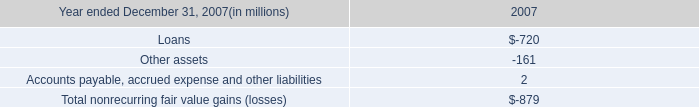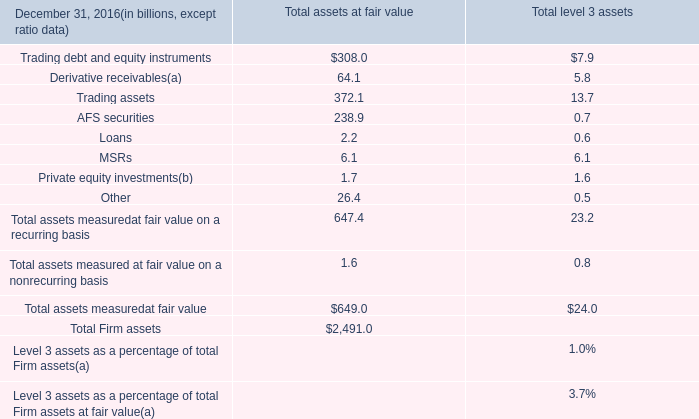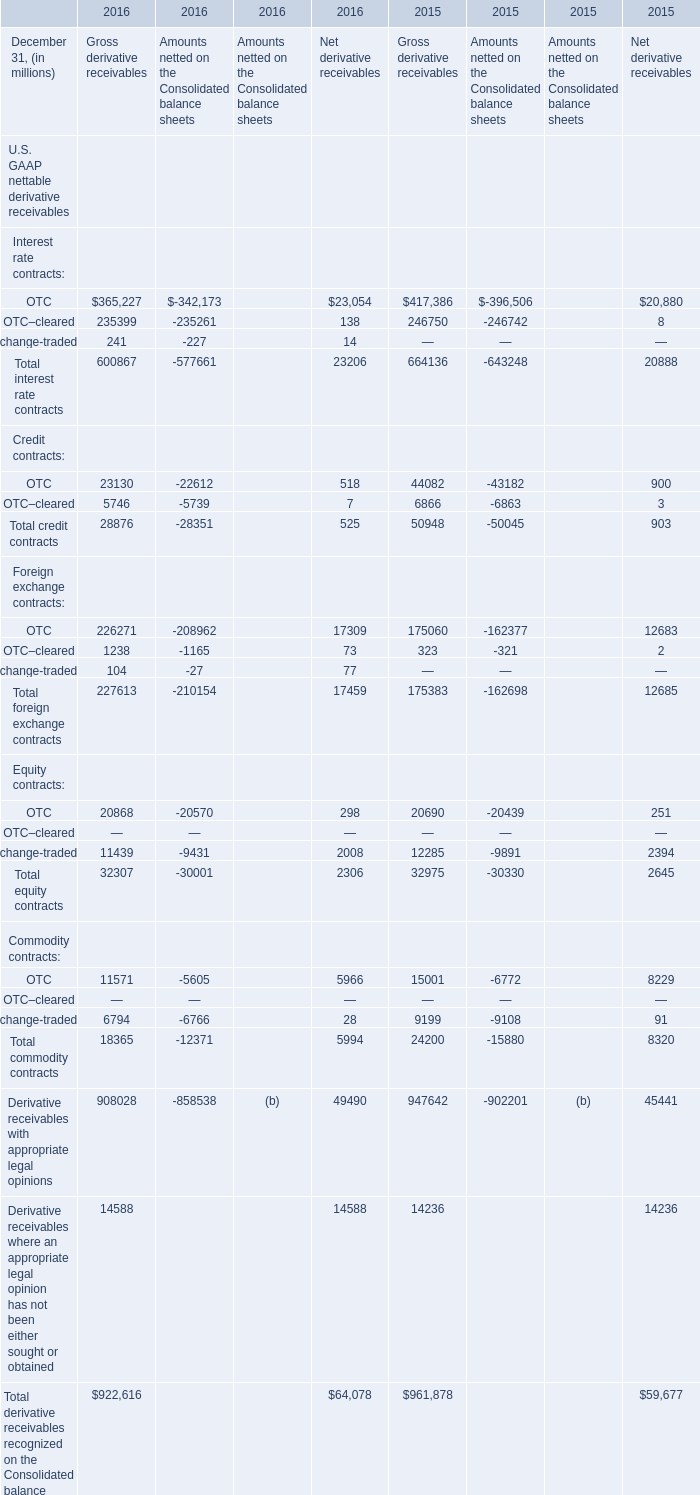What is the sum of Gross derivative receivables in the range of 0 and 250 in 2016? (in million) 
Computations: (241 + 104)
Answer: 345.0. 